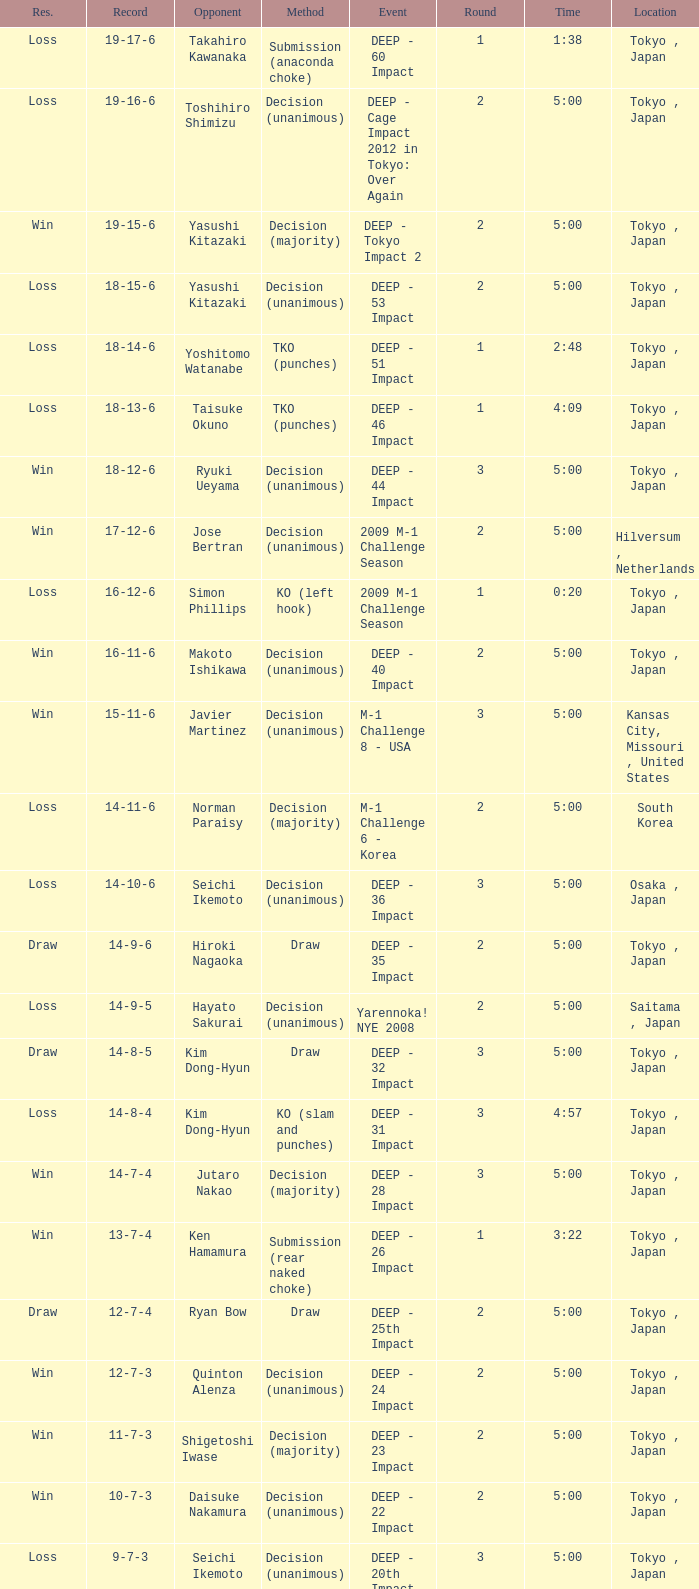What is the location when the method is tko (punches) and the time is 2:48? Tokyo , Japan. 